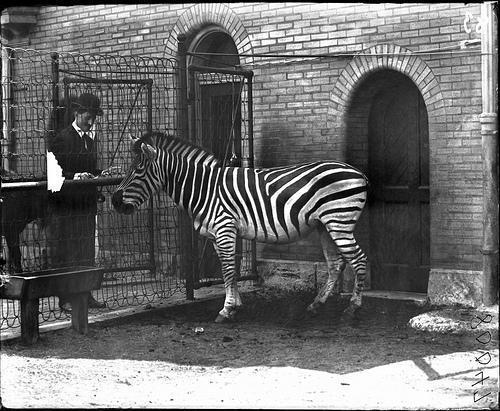How many bears are wearing a cap?
Give a very brief answer. 0. 